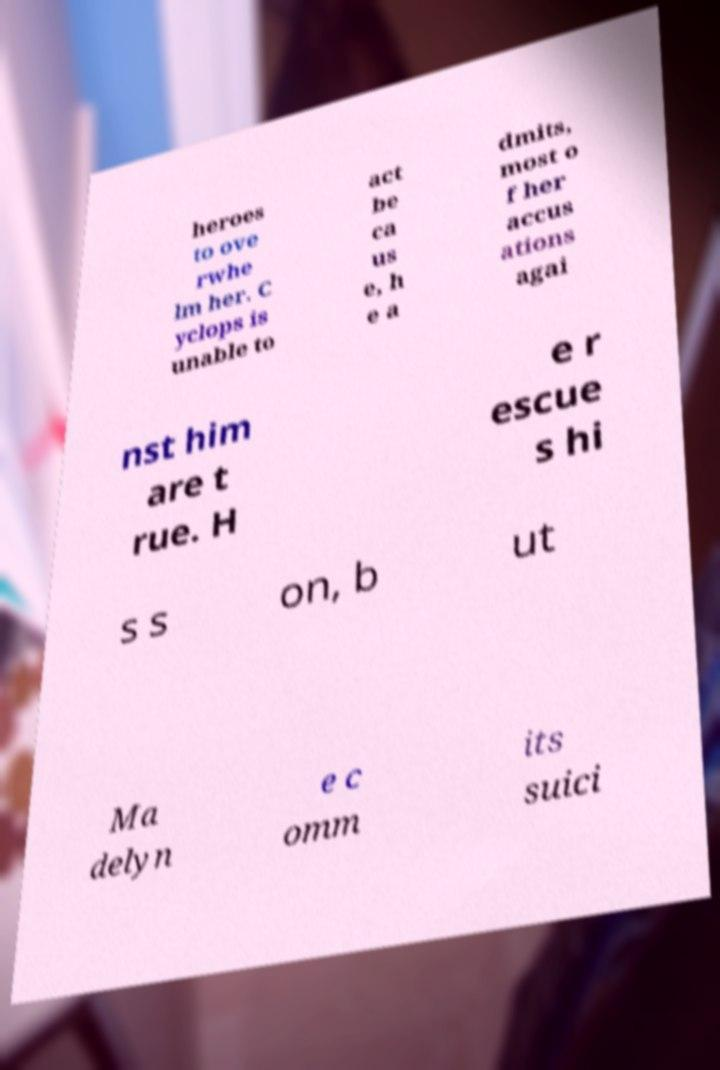What messages or text are displayed in this image? I need them in a readable, typed format. heroes to ove rwhe lm her. C yclops is unable to act be ca us e, h e a dmits, most o f her accus ations agai nst him are t rue. H e r escue s hi s s on, b ut Ma delyn e c omm its suici 